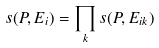<formula> <loc_0><loc_0><loc_500><loc_500>s ( P , E _ { i } ) = \prod _ { k } s ( P , E _ { i k } )</formula> 